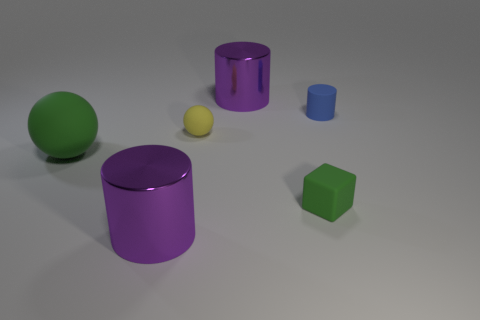What number of metal objects are either blue blocks or small blue objects?
Provide a short and direct response. 0. The large green rubber thing has what shape?
Give a very brief answer. Sphere. How many spheres are made of the same material as the tiny green thing?
Offer a very short reply. 2. There is a big sphere that is made of the same material as the cube; what color is it?
Your answer should be compact. Green. There is a purple object that is in front of the cube; does it have the same size as the large ball?
Your response must be concise. Yes. The other rubber object that is the same shape as the yellow matte object is what color?
Your response must be concise. Green. What shape is the big metallic object that is behind the purple thing to the left of the large purple thing behind the matte cylinder?
Offer a very short reply. Cylinder. Does the blue matte thing have the same shape as the large matte object?
Give a very brief answer. No. What is the shape of the tiny matte object left of the large shiny cylinder behind the yellow matte thing?
Ensure brevity in your answer.  Sphere. Are any large things visible?
Offer a terse response. Yes. 